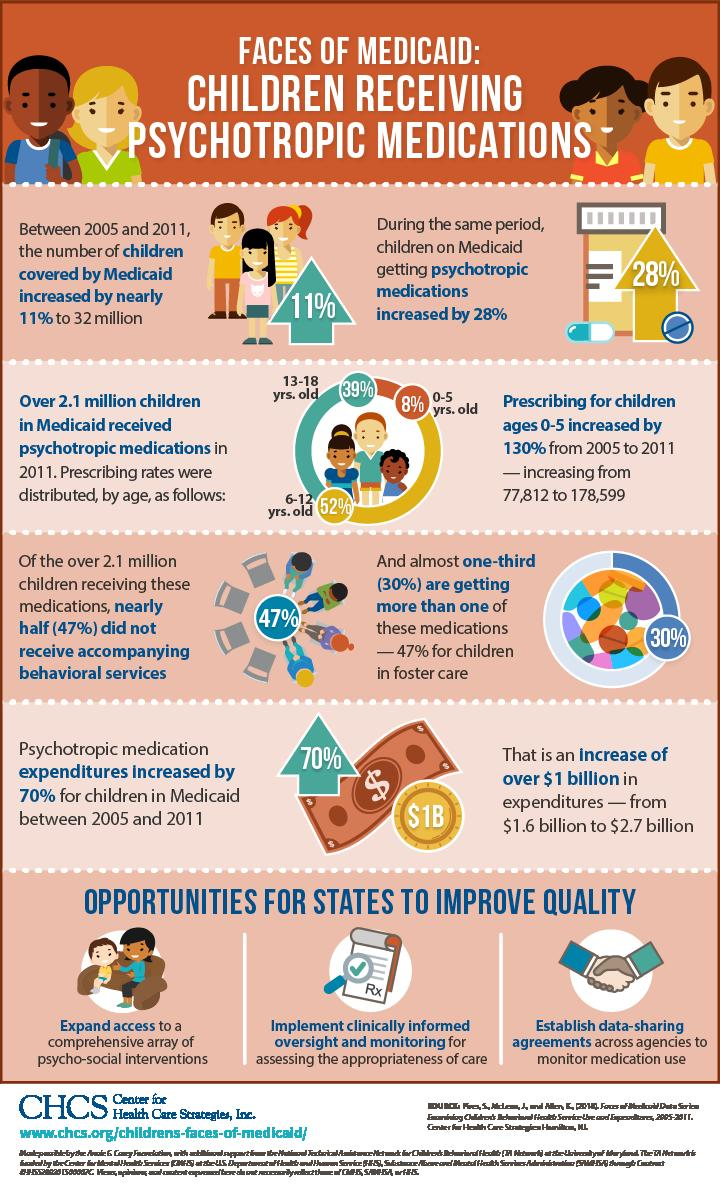Outline some significant characteristics in this image. Among children in the age group of 6-12 years old, those who received psychotropic drugs were more prevalent than those who did not receive such medication. From 2005 to 2011, the number of prescriptions written for children aged 0-5 increased by 100,787, according to data. The prescribing of medications for children under the age of 6 increased by 130%. 